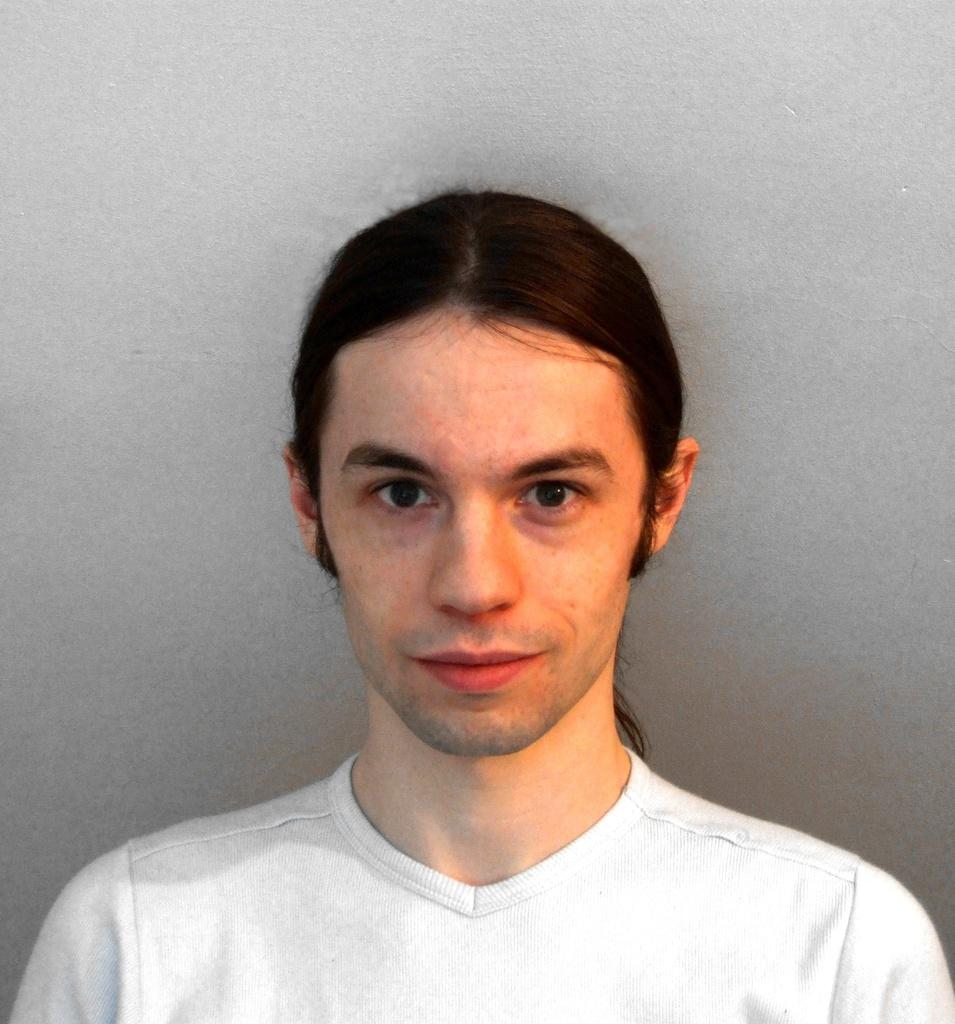What is the main subject of the image? There is a person in the image. What idea does the person have about the importance of wearing shoes on their toes? There is no indication in the image about the person's ideas or thoughts on the importance of wearing shoes on their toes. 